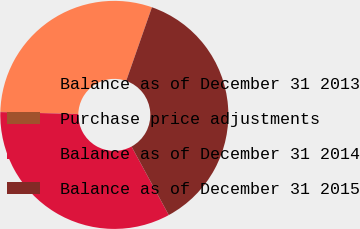<chart> <loc_0><loc_0><loc_500><loc_500><pie_chart><fcel>Balance as of December 31 2013<fcel>Purchase price adjustments<fcel>Balance as of December 31 2014<fcel>Balance as of December 31 2015<nl><fcel>29.92%<fcel>0.04%<fcel>33.32%<fcel>36.72%<nl></chart> 